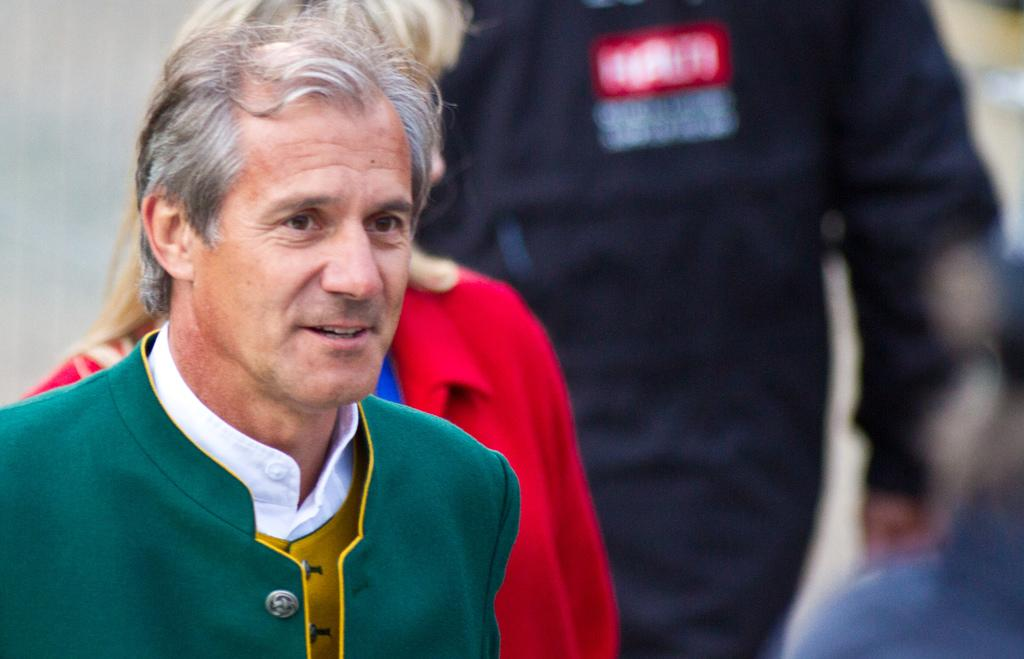Who or what can be seen in the image? There are people in the image. Can you describe the background of the image? The background of the image is blurry. What type of wax is used to create the design on the passenger's shirt in the image? There is no information about a passenger or a shirt with a wax design in the image. 